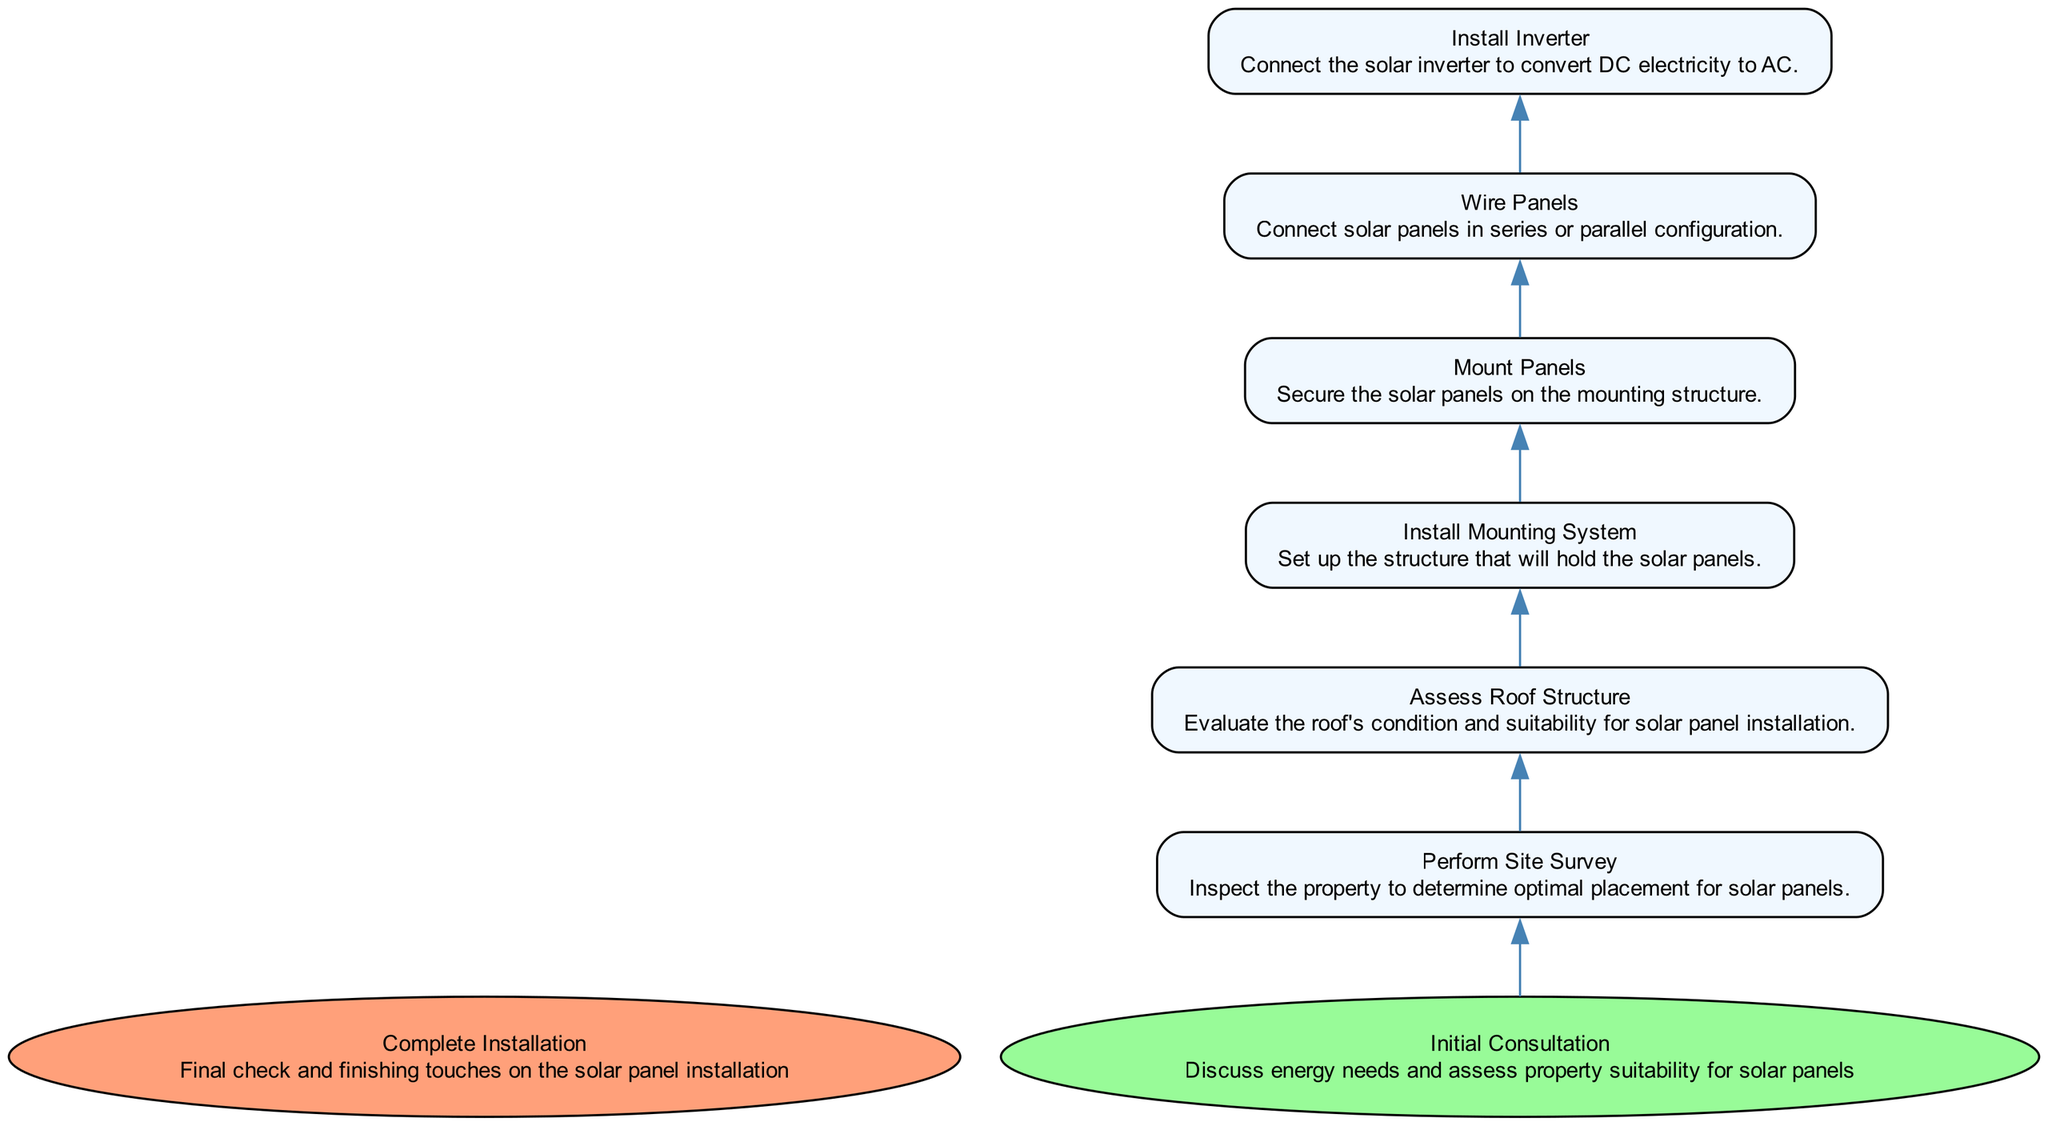What is the first step in the workflow? The first step in the workflow is represented at the bottom of the diagram as "Initial Consultation," where the energy needs and property suitability for solar panels are discussed.
Answer: Initial Consultation How many steps are required before the "Complete Installation"? To reach "Complete Installation," one must go through a series of steps: "Initial Consultation," "Perform Site Survey," "Assess Roof Structure," "Install Mounting System," "Mount Panels," "Wire Panels," and "Install Inverter," totaling 7 steps before the final check.
Answer: 7 What step follows "Wire Panels"? The diagram shows that after "Wire Panels," the next step is "Install Inverter," indicating the sequence of actions in the workflow.
Answer: Install Inverter Which step has the highest level of dependency? The "Complete Installation" step is dependent on multiple earlier steps being completed first, showing it has the highest level of dependency to ensure that everything is properly set up before final checks are made.
Answer: Complete Installation How many dependencies does "Install Mounting System" have? "Install Mounting System" has one dependency, which is "Assess Roof Structure," meaning that it cannot be initiated until the assessment is complete.
Answer: 1 What is the last node indicated in the flowchart? The last node in the flowchart is "Complete Installation," which occurs at the top of the diagram, representing the final stage of the workflow.
Answer: Complete Installation If "Assess Roof Structure" is completed, what is the next step? After "Assess Roof Structure" is completed, the next step is "Install Mounting System," indicating the natural progress of the workflow following this assessment.
Answer: Install Mounting System Which step involves connecting solar panels? The step that involves connecting solar panels is "Wire Panels," as indicated in the diagram description, where solar panels are connected either in series or parallel configuration.
Answer: Wire Panels How many final review steps are in the workflow? There is one final review step in the workflow, which is "Complete Installation," representing the last step where checks and finishing touches are made.
Answer: 1 